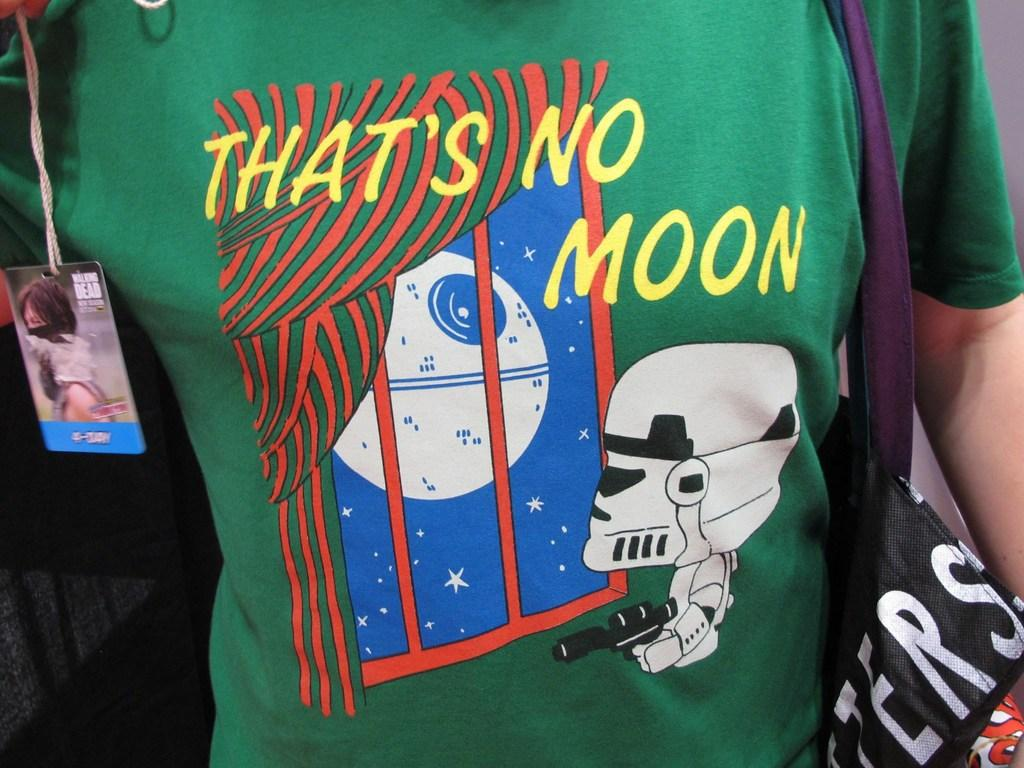Provide a one-sentence caption for the provided image. Storm Stormtrooper looking out of a window and see a big globe and thinks "That's no Moon.". 